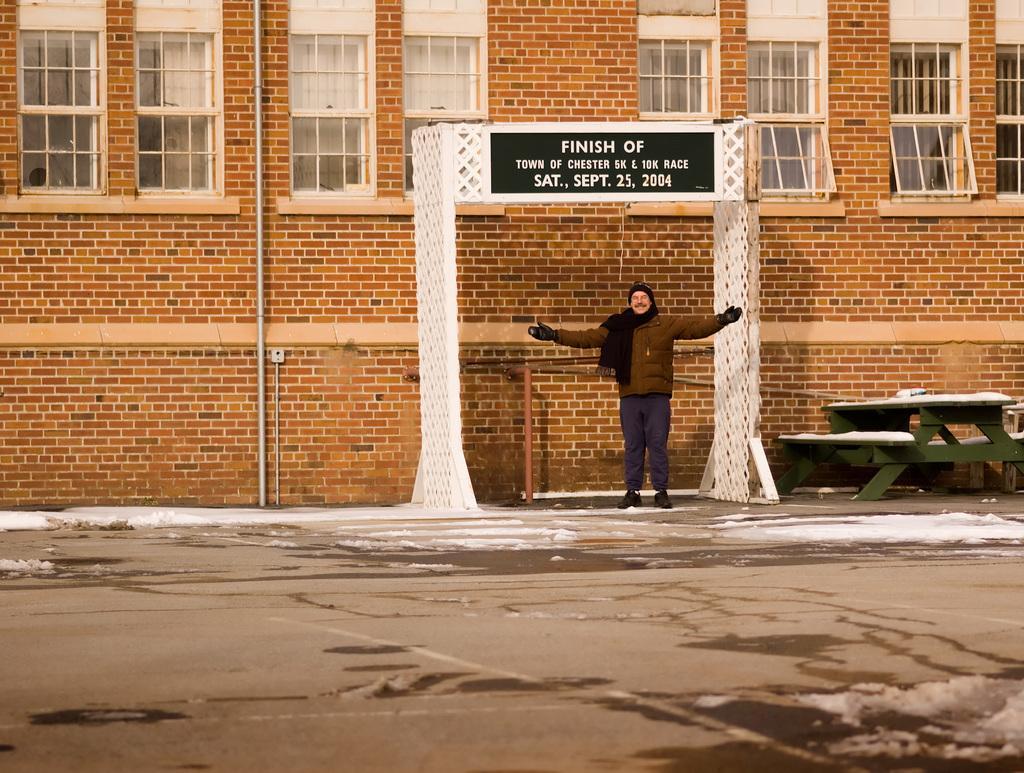Can you describe this image briefly? In this image I can see a person standing on the road. There is a board attached to the arch. In the background there is a building. 